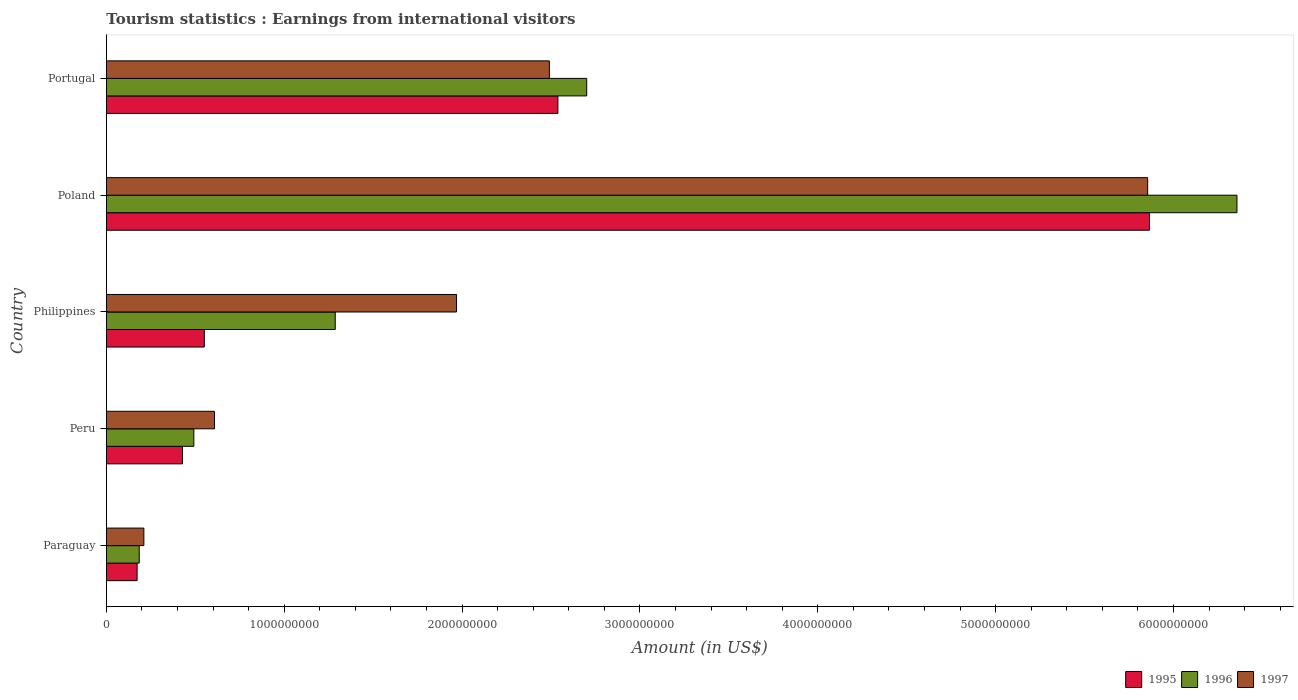How many different coloured bars are there?
Make the answer very short. 3. How many groups of bars are there?
Provide a succinct answer. 5. Are the number of bars per tick equal to the number of legend labels?
Provide a short and direct response. Yes. What is the label of the 5th group of bars from the top?
Provide a succinct answer. Paraguay. What is the earnings from international visitors in 1997 in Peru?
Your answer should be compact. 6.08e+08. Across all countries, what is the maximum earnings from international visitors in 1997?
Offer a terse response. 5.86e+09. Across all countries, what is the minimum earnings from international visitors in 1997?
Provide a succinct answer. 2.11e+08. In which country was the earnings from international visitors in 1995 maximum?
Give a very brief answer. Poland. In which country was the earnings from international visitors in 1997 minimum?
Provide a succinct answer. Paraguay. What is the total earnings from international visitors in 1996 in the graph?
Provide a succinct answer. 1.10e+1. What is the difference between the earnings from international visitors in 1995 in Peru and that in Philippines?
Offer a very short reply. -1.23e+08. What is the difference between the earnings from international visitors in 1995 in Peru and the earnings from international visitors in 1996 in Portugal?
Your answer should be very brief. -2.27e+09. What is the average earnings from international visitors in 1996 per country?
Your answer should be compact. 2.20e+09. What is the difference between the earnings from international visitors in 1995 and earnings from international visitors in 1996 in Poland?
Keep it short and to the point. -4.92e+08. In how many countries, is the earnings from international visitors in 1995 greater than 3400000000 US$?
Keep it short and to the point. 1. What is the ratio of the earnings from international visitors in 1997 in Paraguay to that in Philippines?
Your response must be concise. 0.11. What is the difference between the highest and the second highest earnings from international visitors in 1995?
Offer a terse response. 3.33e+09. What is the difference between the highest and the lowest earnings from international visitors in 1997?
Give a very brief answer. 5.64e+09. Is the sum of the earnings from international visitors in 1997 in Paraguay and Poland greater than the maximum earnings from international visitors in 1996 across all countries?
Ensure brevity in your answer.  No. What does the 1st bar from the top in Paraguay represents?
Your answer should be compact. 1997. What does the 3rd bar from the bottom in Peru represents?
Make the answer very short. 1997. Is it the case that in every country, the sum of the earnings from international visitors in 1997 and earnings from international visitors in 1996 is greater than the earnings from international visitors in 1995?
Give a very brief answer. Yes. Are the values on the major ticks of X-axis written in scientific E-notation?
Keep it short and to the point. No. Does the graph contain any zero values?
Ensure brevity in your answer.  No. How are the legend labels stacked?
Give a very brief answer. Horizontal. What is the title of the graph?
Your response must be concise. Tourism statistics : Earnings from international visitors. Does "1999" appear as one of the legend labels in the graph?
Your response must be concise. No. What is the label or title of the Y-axis?
Give a very brief answer. Country. What is the Amount (in US$) in 1995 in Paraguay?
Your answer should be compact. 1.73e+08. What is the Amount (in US$) in 1996 in Paraguay?
Your response must be concise. 1.85e+08. What is the Amount (in US$) in 1997 in Paraguay?
Provide a succinct answer. 2.11e+08. What is the Amount (in US$) of 1995 in Peru?
Provide a short and direct response. 4.28e+08. What is the Amount (in US$) in 1996 in Peru?
Your answer should be compact. 4.92e+08. What is the Amount (in US$) in 1997 in Peru?
Your answer should be very brief. 6.08e+08. What is the Amount (in US$) in 1995 in Philippines?
Ensure brevity in your answer.  5.51e+08. What is the Amount (in US$) in 1996 in Philippines?
Offer a terse response. 1.29e+09. What is the Amount (in US$) of 1997 in Philippines?
Offer a terse response. 1.97e+09. What is the Amount (in US$) of 1995 in Poland?
Ensure brevity in your answer.  5.86e+09. What is the Amount (in US$) of 1996 in Poland?
Your answer should be compact. 6.36e+09. What is the Amount (in US$) in 1997 in Poland?
Provide a short and direct response. 5.86e+09. What is the Amount (in US$) in 1995 in Portugal?
Your answer should be very brief. 2.54e+09. What is the Amount (in US$) in 1996 in Portugal?
Offer a terse response. 2.70e+09. What is the Amount (in US$) of 1997 in Portugal?
Offer a very short reply. 2.49e+09. Across all countries, what is the maximum Amount (in US$) of 1995?
Your response must be concise. 5.86e+09. Across all countries, what is the maximum Amount (in US$) in 1996?
Your answer should be very brief. 6.36e+09. Across all countries, what is the maximum Amount (in US$) in 1997?
Your answer should be very brief. 5.86e+09. Across all countries, what is the minimum Amount (in US$) of 1995?
Provide a succinct answer. 1.73e+08. Across all countries, what is the minimum Amount (in US$) of 1996?
Make the answer very short. 1.85e+08. Across all countries, what is the minimum Amount (in US$) of 1997?
Offer a very short reply. 2.11e+08. What is the total Amount (in US$) in 1995 in the graph?
Your response must be concise. 9.56e+09. What is the total Amount (in US$) in 1996 in the graph?
Give a very brief answer. 1.10e+1. What is the total Amount (in US$) of 1997 in the graph?
Your answer should be compact. 1.11e+1. What is the difference between the Amount (in US$) in 1995 in Paraguay and that in Peru?
Your answer should be compact. -2.55e+08. What is the difference between the Amount (in US$) in 1996 in Paraguay and that in Peru?
Keep it short and to the point. -3.07e+08. What is the difference between the Amount (in US$) in 1997 in Paraguay and that in Peru?
Offer a very short reply. -3.97e+08. What is the difference between the Amount (in US$) in 1995 in Paraguay and that in Philippines?
Provide a short and direct response. -3.78e+08. What is the difference between the Amount (in US$) of 1996 in Paraguay and that in Philippines?
Provide a short and direct response. -1.10e+09. What is the difference between the Amount (in US$) in 1997 in Paraguay and that in Philippines?
Give a very brief answer. -1.76e+09. What is the difference between the Amount (in US$) of 1995 in Paraguay and that in Poland?
Give a very brief answer. -5.69e+09. What is the difference between the Amount (in US$) of 1996 in Paraguay and that in Poland?
Offer a terse response. -6.17e+09. What is the difference between the Amount (in US$) in 1997 in Paraguay and that in Poland?
Your answer should be very brief. -5.64e+09. What is the difference between the Amount (in US$) of 1995 in Paraguay and that in Portugal?
Make the answer very short. -2.37e+09. What is the difference between the Amount (in US$) of 1996 in Paraguay and that in Portugal?
Make the answer very short. -2.52e+09. What is the difference between the Amount (in US$) in 1997 in Paraguay and that in Portugal?
Make the answer very short. -2.28e+09. What is the difference between the Amount (in US$) in 1995 in Peru and that in Philippines?
Provide a succinct answer. -1.23e+08. What is the difference between the Amount (in US$) of 1996 in Peru and that in Philippines?
Give a very brief answer. -7.95e+08. What is the difference between the Amount (in US$) in 1997 in Peru and that in Philippines?
Your answer should be compact. -1.36e+09. What is the difference between the Amount (in US$) of 1995 in Peru and that in Poland?
Provide a succinct answer. -5.44e+09. What is the difference between the Amount (in US$) in 1996 in Peru and that in Poland?
Your response must be concise. -5.86e+09. What is the difference between the Amount (in US$) in 1997 in Peru and that in Poland?
Keep it short and to the point. -5.25e+09. What is the difference between the Amount (in US$) in 1995 in Peru and that in Portugal?
Your response must be concise. -2.11e+09. What is the difference between the Amount (in US$) in 1996 in Peru and that in Portugal?
Provide a short and direct response. -2.21e+09. What is the difference between the Amount (in US$) in 1997 in Peru and that in Portugal?
Provide a short and direct response. -1.88e+09. What is the difference between the Amount (in US$) in 1995 in Philippines and that in Poland?
Provide a short and direct response. -5.31e+09. What is the difference between the Amount (in US$) of 1996 in Philippines and that in Poland?
Your answer should be compact. -5.07e+09. What is the difference between the Amount (in US$) of 1997 in Philippines and that in Poland?
Ensure brevity in your answer.  -3.89e+09. What is the difference between the Amount (in US$) of 1995 in Philippines and that in Portugal?
Offer a terse response. -1.99e+09. What is the difference between the Amount (in US$) in 1996 in Philippines and that in Portugal?
Keep it short and to the point. -1.41e+09. What is the difference between the Amount (in US$) in 1997 in Philippines and that in Portugal?
Make the answer very short. -5.22e+08. What is the difference between the Amount (in US$) in 1995 in Poland and that in Portugal?
Your response must be concise. 3.33e+09. What is the difference between the Amount (in US$) of 1996 in Poland and that in Portugal?
Make the answer very short. 3.66e+09. What is the difference between the Amount (in US$) in 1997 in Poland and that in Portugal?
Provide a short and direct response. 3.36e+09. What is the difference between the Amount (in US$) of 1995 in Paraguay and the Amount (in US$) of 1996 in Peru?
Your answer should be very brief. -3.19e+08. What is the difference between the Amount (in US$) in 1995 in Paraguay and the Amount (in US$) in 1997 in Peru?
Make the answer very short. -4.35e+08. What is the difference between the Amount (in US$) in 1996 in Paraguay and the Amount (in US$) in 1997 in Peru?
Your response must be concise. -4.23e+08. What is the difference between the Amount (in US$) of 1995 in Paraguay and the Amount (in US$) of 1996 in Philippines?
Offer a terse response. -1.11e+09. What is the difference between the Amount (in US$) of 1995 in Paraguay and the Amount (in US$) of 1997 in Philippines?
Your answer should be very brief. -1.80e+09. What is the difference between the Amount (in US$) in 1996 in Paraguay and the Amount (in US$) in 1997 in Philippines?
Provide a short and direct response. -1.78e+09. What is the difference between the Amount (in US$) in 1995 in Paraguay and the Amount (in US$) in 1996 in Poland?
Keep it short and to the point. -6.18e+09. What is the difference between the Amount (in US$) in 1995 in Paraguay and the Amount (in US$) in 1997 in Poland?
Provide a succinct answer. -5.68e+09. What is the difference between the Amount (in US$) of 1996 in Paraguay and the Amount (in US$) of 1997 in Poland?
Make the answer very short. -5.67e+09. What is the difference between the Amount (in US$) of 1995 in Paraguay and the Amount (in US$) of 1996 in Portugal?
Keep it short and to the point. -2.53e+09. What is the difference between the Amount (in US$) in 1995 in Paraguay and the Amount (in US$) in 1997 in Portugal?
Provide a short and direct response. -2.32e+09. What is the difference between the Amount (in US$) of 1996 in Paraguay and the Amount (in US$) of 1997 in Portugal?
Give a very brief answer. -2.31e+09. What is the difference between the Amount (in US$) in 1995 in Peru and the Amount (in US$) in 1996 in Philippines?
Your response must be concise. -8.59e+08. What is the difference between the Amount (in US$) of 1995 in Peru and the Amount (in US$) of 1997 in Philippines?
Ensure brevity in your answer.  -1.54e+09. What is the difference between the Amount (in US$) in 1996 in Peru and the Amount (in US$) in 1997 in Philippines?
Your answer should be very brief. -1.48e+09. What is the difference between the Amount (in US$) in 1995 in Peru and the Amount (in US$) in 1996 in Poland?
Offer a very short reply. -5.93e+09. What is the difference between the Amount (in US$) in 1995 in Peru and the Amount (in US$) in 1997 in Poland?
Offer a terse response. -5.43e+09. What is the difference between the Amount (in US$) of 1996 in Peru and the Amount (in US$) of 1997 in Poland?
Provide a short and direct response. -5.36e+09. What is the difference between the Amount (in US$) of 1995 in Peru and the Amount (in US$) of 1996 in Portugal?
Offer a terse response. -2.27e+09. What is the difference between the Amount (in US$) of 1995 in Peru and the Amount (in US$) of 1997 in Portugal?
Offer a very short reply. -2.06e+09. What is the difference between the Amount (in US$) of 1996 in Peru and the Amount (in US$) of 1997 in Portugal?
Make the answer very short. -2.00e+09. What is the difference between the Amount (in US$) of 1995 in Philippines and the Amount (in US$) of 1996 in Poland?
Keep it short and to the point. -5.81e+09. What is the difference between the Amount (in US$) in 1995 in Philippines and the Amount (in US$) in 1997 in Poland?
Keep it short and to the point. -5.30e+09. What is the difference between the Amount (in US$) in 1996 in Philippines and the Amount (in US$) in 1997 in Poland?
Offer a very short reply. -4.57e+09. What is the difference between the Amount (in US$) of 1995 in Philippines and the Amount (in US$) of 1996 in Portugal?
Your answer should be compact. -2.15e+09. What is the difference between the Amount (in US$) of 1995 in Philippines and the Amount (in US$) of 1997 in Portugal?
Your response must be concise. -1.94e+09. What is the difference between the Amount (in US$) of 1996 in Philippines and the Amount (in US$) of 1997 in Portugal?
Give a very brief answer. -1.20e+09. What is the difference between the Amount (in US$) in 1995 in Poland and the Amount (in US$) in 1996 in Portugal?
Offer a terse response. 3.16e+09. What is the difference between the Amount (in US$) of 1995 in Poland and the Amount (in US$) of 1997 in Portugal?
Make the answer very short. 3.37e+09. What is the difference between the Amount (in US$) of 1996 in Poland and the Amount (in US$) of 1997 in Portugal?
Make the answer very short. 3.87e+09. What is the average Amount (in US$) in 1995 per country?
Give a very brief answer. 1.91e+09. What is the average Amount (in US$) of 1996 per country?
Give a very brief answer. 2.20e+09. What is the average Amount (in US$) of 1997 per country?
Provide a succinct answer. 2.23e+09. What is the difference between the Amount (in US$) in 1995 and Amount (in US$) in 1996 in Paraguay?
Your response must be concise. -1.20e+07. What is the difference between the Amount (in US$) in 1995 and Amount (in US$) in 1997 in Paraguay?
Make the answer very short. -3.80e+07. What is the difference between the Amount (in US$) in 1996 and Amount (in US$) in 1997 in Paraguay?
Your answer should be very brief. -2.60e+07. What is the difference between the Amount (in US$) in 1995 and Amount (in US$) in 1996 in Peru?
Your answer should be compact. -6.40e+07. What is the difference between the Amount (in US$) of 1995 and Amount (in US$) of 1997 in Peru?
Your response must be concise. -1.80e+08. What is the difference between the Amount (in US$) of 1996 and Amount (in US$) of 1997 in Peru?
Give a very brief answer. -1.16e+08. What is the difference between the Amount (in US$) in 1995 and Amount (in US$) in 1996 in Philippines?
Give a very brief answer. -7.36e+08. What is the difference between the Amount (in US$) in 1995 and Amount (in US$) in 1997 in Philippines?
Provide a short and direct response. -1.42e+09. What is the difference between the Amount (in US$) of 1996 and Amount (in US$) of 1997 in Philippines?
Provide a succinct answer. -6.82e+08. What is the difference between the Amount (in US$) in 1995 and Amount (in US$) in 1996 in Poland?
Offer a terse response. -4.92e+08. What is the difference between the Amount (in US$) of 1995 and Amount (in US$) of 1997 in Poland?
Your answer should be very brief. 1.00e+07. What is the difference between the Amount (in US$) in 1996 and Amount (in US$) in 1997 in Poland?
Provide a short and direct response. 5.02e+08. What is the difference between the Amount (in US$) of 1995 and Amount (in US$) of 1996 in Portugal?
Offer a very short reply. -1.62e+08. What is the difference between the Amount (in US$) of 1995 and Amount (in US$) of 1997 in Portugal?
Offer a terse response. 4.80e+07. What is the difference between the Amount (in US$) of 1996 and Amount (in US$) of 1997 in Portugal?
Your response must be concise. 2.10e+08. What is the ratio of the Amount (in US$) of 1995 in Paraguay to that in Peru?
Offer a terse response. 0.4. What is the ratio of the Amount (in US$) of 1996 in Paraguay to that in Peru?
Keep it short and to the point. 0.38. What is the ratio of the Amount (in US$) of 1997 in Paraguay to that in Peru?
Give a very brief answer. 0.35. What is the ratio of the Amount (in US$) in 1995 in Paraguay to that in Philippines?
Offer a terse response. 0.31. What is the ratio of the Amount (in US$) of 1996 in Paraguay to that in Philippines?
Offer a very short reply. 0.14. What is the ratio of the Amount (in US$) in 1997 in Paraguay to that in Philippines?
Offer a very short reply. 0.11. What is the ratio of the Amount (in US$) in 1995 in Paraguay to that in Poland?
Your answer should be compact. 0.03. What is the ratio of the Amount (in US$) in 1996 in Paraguay to that in Poland?
Provide a succinct answer. 0.03. What is the ratio of the Amount (in US$) in 1997 in Paraguay to that in Poland?
Offer a terse response. 0.04. What is the ratio of the Amount (in US$) of 1995 in Paraguay to that in Portugal?
Provide a succinct answer. 0.07. What is the ratio of the Amount (in US$) in 1996 in Paraguay to that in Portugal?
Ensure brevity in your answer.  0.07. What is the ratio of the Amount (in US$) in 1997 in Paraguay to that in Portugal?
Offer a terse response. 0.08. What is the ratio of the Amount (in US$) of 1995 in Peru to that in Philippines?
Make the answer very short. 0.78. What is the ratio of the Amount (in US$) in 1996 in Peru to that in Philippines?
Offer a terse response. 0.38. What is the ratio of the Amount (in US$) in 1997 in Peru to that in Philippines?
Provide a short and direct response. 0.31. What is the ratio of the Amount (in US$) of 1995 in Peru to that in Poland?
Offer a terse response. 0.07. What is the ratio of the Amount (in US$) of 1996 in Peru to that in Poland?
Your answer should be compact. 0.08. What is the ratio of the Amount (in US$) in 1997 in Peru to that in Poland?
Make the answer very short. 0.1. What is the ratio of the Amount (in US$) in 1995 in Peru to that in Portugal?
Your answer should be compact. 0.17. What is the ratio of the Amount (in US$) of 1996 in Peru to that in Portugal?
Provide a succinct answer. 0.18. What is the ratio of the Amount (in US$) in 1997 in Peru to that in Portugal?
Offer a very short reply. 0.24. What is the ratio of the Amount (in US$) of 1995 in Philippines to that in Poland?
Your response must be concise. 0.09. What is the ratio of the Amount (in US$) in 1996 in Philippines to that in Poland?
Offer a terse response. 0.2. What is the ratio of the Amount (in US$) in 1997 in Philippines to that in Poland?
Provide a succinct answer. 0.34. What is the ratio of the Amount (in US$) in 1995 in Philippines to that in Portugal?
Your answer should be compact. 0.22. What is the ratio of the Amount (in US$) in 1996 in Philippines to that in Portugal?
Give a very brief answer. 0.48. What is the ratio of the Amount (in US$) of 1997 in Philippines to that in Portugal?
Keep it short and to the point. 0.79. What is the ratio of the Amount (in US$) in 1995 in Poland to that in Portugal?
Offer a terse response. 2.31. What is the ratio of the Amount (in US$) of 1996 in Poland to that in Portugal?
Your answer should be very brief. 2.35. What is the ratio of the Amount (in US$) in 1997 in Poland to that in Portugal?
Give a very brief answer. 2.35. What is the difference between the highest and the second highest Amount (in US$) in 1995?
Offer a terse response. 3.33e+09. What is the difference between the highest and the second highest Amount (in US$) in 1996?
Provide a succinct answer. 3.66e+09. What is the difference between the highest and the second highest Amount (in US$) in 1997?
Offer a very short reply. 3.36e+09. What is the difference between the highest and the lowest Amount (in US$) of 1995?
Your response must be concise. 5.69e+09. What is the difference between the highest and the lowest Amount (in US$) in 1996?
Your response must be concise. 6.17e+09. What is the difference between the highest and the lowest Amount (in US$) in 1997?
Give a very brief answer. 5.64e+09. 